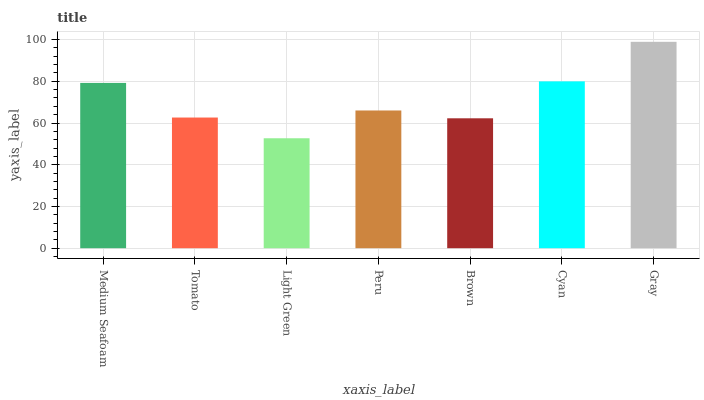Is Light Green the minimum?
Answer yes or no. Yes. Is Gray the maximum?
Answer yes or no. Yes. Is Tomato the minimum?
Answer yes or no. No. Is Tomato the maximum?
Answer yes or no. No. Is Medium Seafoam greater than Tomato?
Answer yes or no. Yes. Is Tomato less than Medium Seafoam?
Answer yes or no. Yes. Is Tomato greater than Medium Seafoam?
Answer yes or no. No. Is Medium Seafoam less than Tomato?
Answer yes or no. No. Is Peru the high median?
Answer yes or no. Yes. Is Peru the low median?
Answer yes or no. Yes. Is Cyan the high median?
Answer yes or no. No. Is Gray the low median?
Answer yes or no. No. 